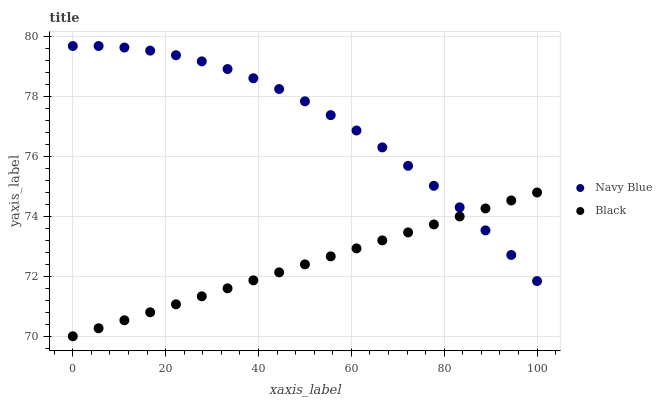Does Black have the minimum area under the curve?
Answer yes or no. Yes. Does Navy Blue have the maximum area under the curve?
Answer yes or no. Yes. Does Black have the maximum area under the curve?
Answer yes or no. No. Is Black the smoothest?
Answer yes or no. Yes. Is Navy Blue the roughest?
Answer yes or no. Yes. Is Black the roughest?
Answer yes or no. No. Does Black have the lowest value?
Answer yes or no. Yes. Does Navy Blue have the highest value?
Answer yes or no. Yes. Does Black have the highest value?
Answer yes or no. No. Does Navy Blue intersect Black?
Answer yes or no. Yes. Is Navy Blue less than Black?
Answer yes or no. No. Is Navy Blue greater than Black?
Answer yes or no. No. 